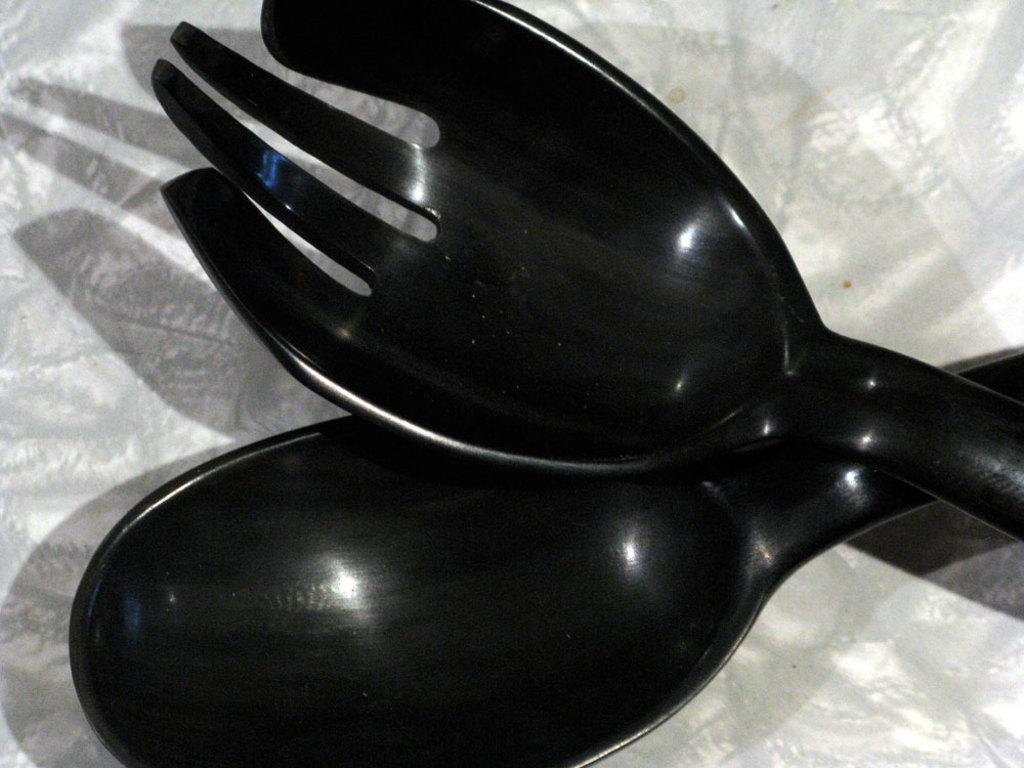What color are the utensils in the image? The utensils in the image are black. What specific utensils can be seen in the image? There is a black color spoon and a black color fork in the image. Are there any ants crawling on the black color spoon in the image? There are no ants present in the image. 